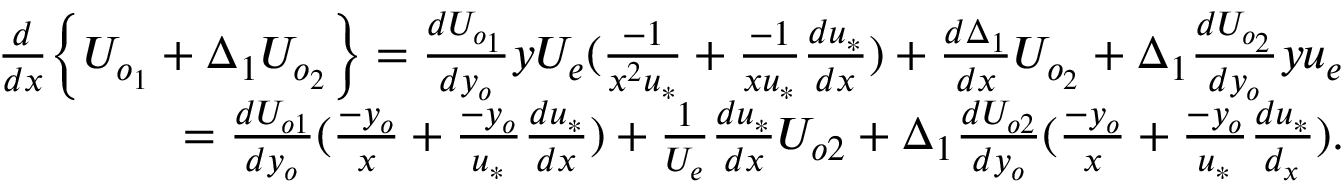Convert formula to latex. <formula><loc_0><loc_0><loc_500><loc_500>\begin{array} { r } { \frac { d } { d x } \left \{ U _ { o _ { 1 } } + \Delta _ { 1 } U _ { o _ { 2 } } \right \} = \frac { d U _ { o _ { 1 } } } { d y _ { o } } y U _ { e } ( \frac { - 1 } { x ^ { 2 } u _ { * } } + \frac { - 1 } { x u _ { * } } \frac { d u _ { * } } { d x } ) + \frac { d \Delta _ { 1 } } { d x } U _ { o _ { 2 } } + \Delta _ { 1 } \frac { d U _ { o _ { 2 } } } { d y _ { o } } y u _ { e } } \\ { = \frac { d U _ { o 1 } } { d y _ { o } } ( \frac { - y _ { o } } { x } + \frac { - y _ { o } } { u _ { * } } \frac { d u _ { * } } { d x } ) + \frac { 1 } { U _ { e } } \frac { d u _ { * } } { d x } U _ { o 2 } + \Delta _ { 1 } \frac { d U _ { o 2 } } { d y _ { o } } ( \frac { - y _ { o } } { x } + \frac { - y _ { o } } { u _ { * } } \frac { d u _ { * } } { d _ { x } } ) . } \end{array}</formula> 